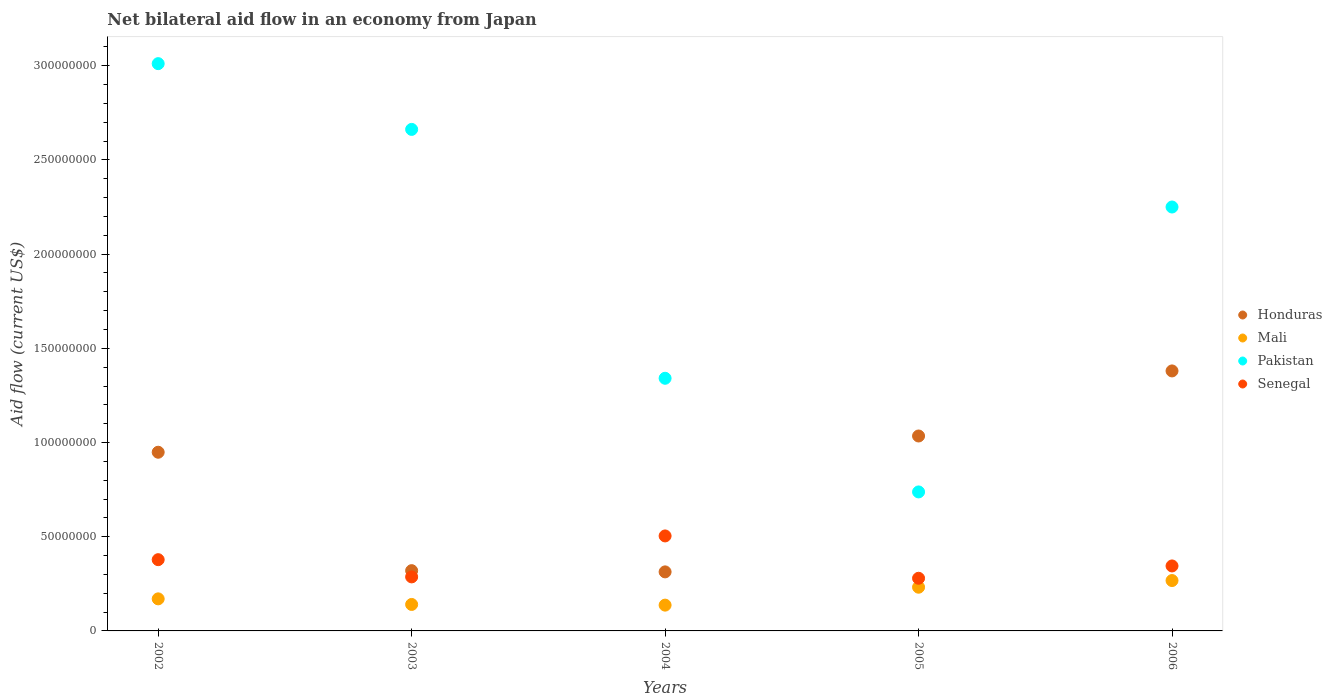Is the number of dotlines equal to the number of legend labels?
Your answer should be very brief. Yes. What is the net bilateral aid flow in Mali in 2002?
Give a very brief answer. 1.70e+07. Across all years, what is the maximum net bilateral aid flow in Pakistan?
Provide a succinct answer. 3.01e+08. Across all years, what is the minimum net bilateral aid flow in Mali?
Give a very brief answer. 1.37e+07. In which year was the net bilateral aid flow in Honduras minimum?
Provide a succinct answer. 2004. What is the total net bilateral aid flow in Senegal in the graph?
Make the answer very short. 1.79e+08. What is the difference between the net bilateral aid flow in Mali in 2002 and that in 2005?
Offer a terse response. -6.18e+06. What is the difference between the net bilateral aid flow in Mali in 2003 and the net bilateral aid flow in Senegal in 2005?
Give a very brief answer. -1.39e+07. What is the average net bilateral aid flow in Mali per year?
Ensure brevity in your answer.  1.89e+07. In the year 2004, what is the difference between the net bilateral aid flow in Mali and net bilateral aid flow in Senegal?
Offer a terse response. -3.67e+07. What is the ratio of the net bilateral aid flow in Honduras in 2004 to that in 2006?
Your answer should be very brief. 0.23. What is the difference between the highest and the second highest net bilateral aid flow in Honduras?
Ensure brevity in your answer.  3.45e+07. What is the difference between the highest and the lowest net bilateral aid flow in Honduras?
Provide a short and direct response. 1.07e+08. In how many years, is the net bilateral aid flow in Pakistan greater than the average net bilateral aid flow in Pakistan taken over all years?
Provide a short and direct response. 3. Is it the case that in every year, the sum of the net bilateral aid flow in Mali and net bilateral aid flow in Senegal  is greater than the sum of net bilateral aid flow in Honduras and net bilateral aid flow in Pakistan?
Your response must be concise. No. Is the net bilateral aid flow in Mali strictly less than the net bilateral aid flow in Honduras over the years?
Make the answer very short. Yes. How many dotlines are there?
Your response must be concise. 4. How many years are there in the graph?
Keep it short and to the point. 5. What is the difference between two consecutive major ticks on the Y-axis?
Keep it short and to the point. 5.00e+07. Does the graph contain any zero values?
Keep it short and to the point. No. Where does the legend appear in the graph?
Your answer should be compact. Center right. What is the title of the graph?
Keep it short and to the point. Net bilateral aid flow in an economy from Japan. What is the Aid flow (current US$) in Honduras in 2002?
Ensure brevity in your answer.  9.48e+07. What is the Aid flow (current US$) of Mali in 2002?
Your answer should be compact. 1.70e+07. What is the Aid flow (current US$) of Pakistan in 2002?
Make the answer very short. 3.01e+08. What is the Aid flow (current US$) in Senegal in 2002?
Offer a very short reply. 3.78e+07. What is the Aid flow (current US$) in Honduras in 2003?
Your answer should be compact. 3.20e+07. What is the Aid flow (current US$) of Mali in 2003?
Your answer should be compact. 1.40e+07. What is the Aid flow (current US$) of Pakistan in 2003?
Provide a succinct answer. 2.66e+08. What is the Aid flow (current US$) in Senegal in 2003?
Your response must be concise. 2.87e+07. What is the Aid flow (current US$) of Honduras in 2004?
Offer a terse response. 3.13e+07. What is the Aid flow (current US$) in Mali in 2004?
Your answer should be compact. 1.37e+07. What is the Aid flow (current US$) of Pakistan in 2004?
Your response must be concise. 1.34e+08. What is the Aid flow (current US$) in Senegal in 2004?
Your answer should be compact. 5.04e+07. What is the Aid flow (current US$) in Honduras in 2005?
Make the answer very short. 1.03e+08. What is the Aid flow (current US$) in Mali in 2005?
Give a very brief answer. 2.32e+07. What is the Aid flow (current US$) in Pakistan in 2005?
Your answer should be compact. 7.38e+07. What is the Aid flow (current US$) of Senegal in 2005?
Make the answer very short. 2.80e+07. What is the Aid flow (current US$) in Honduras in 2006?
Make the answer very short. 1.38e+08. What is the Aid flow (current US$) of Mali in 2006?
Provide a short and direct response. 2.67e+07. What is the Aid flow (current US$) of Pakistan in 2006?
Offer a very short reply. 2.25e+08. What is the Aid flow (current US$) in Senegal in 2006?
Provide a succinct answer. 3.45e+07. Across all years, what is the maximum Aid flow (current US$) of Honduras?
Your answer should be compact. 1.38e+08. Across all years, what is the maximum Aid flow (current US$) in Mali?
Provide a succinct answer. 2.67e+07. Across all years, what is the maximum Aid flow (current US$) of Pakistan?
Offer a terse response. 3.01e+08. Across all years, what is the maximum Aid flow (current US$) in Senegal?
Ensure brevity in your answer.  5.04e+07. Across all years, what is the minimum Aid flow (current US$) of Honduras?
Make the answer very short. 3.13e+07. Across all years, what is the minimum Aid flow (current US$) in Mali?
Make the answer very short. 1.37e+07. Across all years, what is the minimum Aid flow (current US$) of Pakistan?
Your response must be concise. 7.38e+07. Across all years, what is the minimum Aid flow (current US$) in Senegal?
Your response must be concise. 2.80e+07. What is the total Aid flow (current US$) in Honduras in the graph?
Keep it short and to the point. 4.00e+08. What is the total Aid flow (current US$) in Mali in the graph?
Your response must be concise. 9.47e+07. What is the total Aid flow (current US$) of Pakistan in the graph?
Provide a short and direct response. 1.00e+09. What is the total Aid flow (current US$) in Senegal in the graph?
Give a very brief answer. 1.79e+08. What is the difference between the Aid flow (current US$) in Honduras in 2002 and that in 2003?
Your response must be concise. 6.29e+07. What is the difference between the Aid flow (current US$) of Mali in 2002 and that in 2003?
Ensure brevity in your answer.  2.97e+06. What is the difference between the Aid flow (current US$) in Pakistan in 2002 and that in 2003?
Provide a short and direct response. 3.49e+07. What is the difference between the Aid flow (current US$) in Senegal in 2002 and that in 2003?
Offer a very short reply. 9.14e+06. What is the difference between the Aid flow (current US$) in Honduras in 2002 and that in 2004?
Keep it short and to the point. 6.35e+07. What is the difference between the Aid flow (current US$) in Mali in 2002 and that in 2004?
Your response must be concise. 3.33e+06. What is the difference between the Aid flow (current US$) of Pakistan in 2002 and that in 2004?
Your answer should be very brief. 1.67e+08. What is the difference between the Aid flow (current US$) of Senegal in 2002 and that in 2004?
Provide a succinct answer. -1.26e+07. What is the difference between the Aid flow (current US$) of Honduras in 2002 and that in 2005?
Give a very brief answer. -8.62e+06. What is the difference between the Aid flow (current US$) of Mali in 2002 and that in 2005?
Keep it short and to the point. -6.18e+06. What is the difference between the Aid flow (current US$) in Pakistan in 2002 and that in 2005?
Your answer should be very brief. 2.27e+08. What is the difference between the Aid flow (current US$) of Senegal in 2002 and that in 2005?
Make the answer very short. 9.87e+06. What is the difference between the Aid flow (current US$) of Honduras in 2002 and that in 2006?
Your answer should be compact. -4.32e+07. What is the difference between the Aid flow (current US$) of Mali in 2002 and that in 2006?
Give a very brief answer. -9.72e+06. What is the difference between the Aid flow (current US$) in Pakistan in 2002 and that in 2006?
Make the answer very short. 7.61e+07. What is the difference between the Aid flow (current US$) of Senegal in 2002 and that in 2006?
Ensure brevity in your answer.  3.33e+06. What is the difference between the Aid flow (current US$) of Honduras in 2003 and that in 2004?
Offer a terse response. 6.50e+05. What is the difference between the Aid flow (current US$) in Mali in 2003 and that in 2004?
Your response must be concise. 3.60e+05. What is the difference between the Aid flow (current US$) of Pakistan in 2003 and that in 2004?
Offer a terse response. 1.32e+08. What is the difference between the Aid flow (current US$) in Senegal in 2003 and that in 2004?
Provide a short and direct response. -2.17e+07. What is the difference between the Aid flow (current US$) in Honduras in 2003 and that in 2005?
Offer a very short reply. -7.15e+07. What is the difference between the Aid flow (current US$) of Mali in 2003 and that in 2005?
Your response must be concise. -9.15e+06. What is the difference between the Aid flow (current US$) in Pakistan in 2003 and that in 2005?
Provide a short and direct response. 1.92e+08. What is the difference between the Aid flow (current US$) in Senegal in 2003 and that in 2005?
Your answer should be very brief. 7.30e+05. What is the difference between the Aid flow (current US$) in Honduras in 2003 and that in 2006?
Offer a terse response. -1.06e+08. What is the difference between the Aid flow (current US$) in Mali in 2003 and that in 2006?
Your answer should be very brief. -1.27e+07. What is the difference between the Aid flow (current US$) in Pakistan in 2003 and that in 2006?
Your response must be concise. 4.12e+07. What is the difference between the Aid flow (current US$) in Senegal in 2003 and that in 2006?
Your response must be concise. -5.81e+06. What is the difference between the Aid flow (current US$) of Honduras in 2004 and that in 2005?
Provide a succinct answer. -7.21e+07. What is the difference between the Aid flow (current US$) of Mali in 2004 and that in 2005?
Offer a very short reply. -9.51e+06. What is the difference between the Aid flow (current US$) in Pakistan in 2004 and that in 2005?
Give a very brief answer. 6.03e+07. What is the difference between the Aid flow (current US$) of Senegal in 2004 and that in 2005?
Offer a very short reply. 2.25e+07. What is the difference between the Aid flow (current US$) of Honduras in 2004 and that in 2006?
Offer a very short reply. -1.07e+08. What is the difference between the Aid flow (current US$) of Mali in 2004 and that in 2006?
Offer a very short reply. -1.30e+07. What is the difference between the Aid flow (current US$) in Pakistan in 2004 and that in 2006?
Provide a succinct answer. -9.09e+07. What is the difference between the Aid flow (current US$) of Senegal in 2004 and that in 2006?
Your response must be concise. 1.59e+07. What is the difference between the Aid flow (current US$) of Honduras in 2005 and that in 2006?
Keep it short and to the point. -3.45e+07. What is the difference between the Aid flow (current US$) of Mali in 2005 and that in 2006?
Your response must be concise. -3.54e+06. What is the difference between the Aid flow (current US$) in Pakistan in 2005 and that in 2006?
Offer a terse response. -1.51e+08. What is the difference between the Aid flow (current US$) of Senegal in 2005 and that in 2006?
Keep it short and to the point. -6.54e+06. What is the difference between the Aid flow (current US$) in Honduras in 2002 and the Aid flow (current US$) in Mali in 2003?
Keep it short and to the point. 8.08e+07. What is the difference between the Aid flow (current US$) in Honduras in 2002 and the Aid flow (current US$) in Pakistan in 2003?
Offer a very short reply. -1.71e+08. What is the difference between the Aid flow (current US$) in Honduras in 2002 and the Aid flow (current US$) in Senegal in 2003?
Provide a short and direct response. 6.62e+07. What is the difference between the Aid flow (current US$) in Mali in 2002 and the Aid flow (current US$) in Pakistan in 2003?
Provide a succinct answer. -2.49e+08. What is the difference between the Aid flow (current US$) in Mali in 2002 and the Aid flow (current US$) in Senegal in 2003?
Provide a short and direct response. -1.17e+07. What is the difference between the Aid flow (current US$) in Pakistan in 2002 and the Aid flow (current US$) in Senegal in 2003?
Offer a terse response. 2.72e+08. What is the difference between the Aid flow (current US$) of Honduras in 2002 and the Aid flow (current US$) of Mali in 2004?
Provide a short and direct response. 8.12e+07. What is the difference between the Aid flow (current US$) of Honduras in 2002 and the Aid flow (current US$) of Pakistan in 2004?
Your response must be concise. -3.93e+07. What is the difference between the Aid flow (current US$) of Honduras in 2002 and the Aid flow (current US$) of Senegal in 2004?
Keep it short and to the point. 4.44e+07. What is the difference between the Aid flow (current US$) in Mali in 2002 and the Aid flow (current US$) in Pakistan in 2004?
Your answer should be compact. -1.17e+08. What is the difference between the Aid flow (current US$) in Mali in 2002 and the Aid flow (current US$) in Senegal in 2004?
Your answer should be very brief. -3.34e+07. What is the difference between the Aid flow (current US$) of Pakistan in 2002 and the Aid flow (current US$) of Senegal in 2004?
Provide a succinct answer. 2.51e+08. What is the difference between the Aid flow (current US$) in Honduras in 2002 and the Aid flow (current US$) in Mali in 2005?
Make the answer very short. 7.16e+07. What is the difference between the Aid flow (current US$) of Honduras in 2002 and the Aid flow (current US$) of Pakistan in 2005?
Your answer should be compact. 2.11e+07. What is the difference between the Aid flow (current US$) in Honduras in 2002 and the Aid flow (current US$) in Senegal in 2005?
Offer a very short reply. 6.69e+07. What is the difference between the Aid flow (current US$) in Mali in 2002 and the Aid flow (current US$) in Pakistan in 2005?
Ensure brevity in your answer.  -5.68e+07. What is the difference between the Aid flow (current US$) in Mali in 2002 and the Aid flow (current US$) in Senegal in 2005?
Your answer should be compact. -1.09e+07. What is the difference between the Aid flow (current US$) in Pakistan in 2002 and the Aid flow (current US$) in Senegal in 2005?
Your response must be concise. 2.73e+08. What is the difference between the Aid flow (current US$) of Honduras in 2002 and the Aid flow (current US$) of Mali in 2006?
Your answer should be very brief. 6.81e+07. What is the difference between the Aid flow (current US$) of Honduras in 2002 and the Aid flow (current US$) of Pakistan in 2006?
Ensure brevity in your answer.  -1.30e+08. What is the difference between the Aid flow (current US$) in Honduras in 2002 and the Aid flow (current US$) in Senegal in 2006?
Provide a succinct answer. 6.04e+07. What is the difference between the Aid flow (current US$) of Mali in 2002 and the Aid flow (current US$) of Pakistan in 2006?
Provide a short and direct response. -2.08e+08. What is the difference between the Aid flow (current US$) of Mali in 2002 and the Aid flow (current US$) of Senegal in 2006?
Keep it short and to the point. -1.75e+07. What is the difference between the Aid flow (current US$) in Pakistan in 2002 and the Aid flow (current US$) in Senegal in 2006?
Offer a terse response. 2.67e+08. What is the difference between the Aid flow (current US$) in Honduras in 2003 and the Aid flow (current US$) in Mali in 2004?
Provide a short and direct response. 1.83e+07. What is the difference between the Aid flow (current US$) of Honduras in 2003 and the Aid flow (current US$) of Pakistan in 2004?
Provide a succinct answer. -1.02e+08. What is the difference between the Aid flow (current US$) in Honduras in 2003 and the Aid flow (current US$) in Senegal in 2004?
Offer a very short reply. -1.84e+07. What is the difference between the Aid flow (current US$) of Mali in 2003 and the Aid flow (current US$) of Pakistan in 2004?
Your answer should be very brief. -1.20e+08. What is the difference between the Aid flow (current US$) of Mali in 2003 and the Aid flow (current US$) of Senegal in 2004?
Provide a short and direct response. -3.64e+07. What is the difference between the Aid flow (current US$) of Pakistan in 2003 and the Aid flow (current US$) of Senegal in 2004?
Keep it short and to the point. 2.16e+08. What is the difference between the Aid flow (current US$) in Honduras in 2003 and the Aid flow (current US$) in Mali in 2005?
Make the answer very short. 8.79e+06. What is the difference between the Aid flow (current US$) in Honduras in 2003 and the Aid flow (current US$) in Pakistan in 2005?
Provide a succinct answer. -4.18e+07. What is the difference between the Aid flow (current US$) in Honduras in 2003 and the Aid flow (current US$) in Senegal in 2005?
Make the answer very short. 4.04e+06. What is the difference between the Aid flow (current US$) in Mali in 2003 and the Aid flow (current US$) in Pakistan in 2005?
Provide a succinct answer. -5.97e+07. What is the difference between the Aid flow (current US$) in Mali in 2003 and the Aid flow (current US$) in Senegal in 2005?
Offer a terse response. -1.39e+07. What is the difference between the Aid flow (current US$) in Pakistan in 2003 and the Aid flow (current US$) in Senegal in 2005?
Offer a terse response. 2.38e+08. What is the difference between the Aid flow (current US$) of Honduras in 2003 and the Aid flow (current US$) of Mali in 2006?
Offer a very short reply. 5.25e+06. What is the difference between the Aid flow (current US$) in Honduras in 2003 and the Aid flow (current US$) in Pakistan in 2006?
Your answer should be very brief. -1.93e+08. What is the difference between the Aid flow (current US$) in Honduras in 2003 and the Aid flow (current US$) in Senegal in 2006?
Offer a terse response. -2.50e+06. What is the difference between the Aid flow (current US$) in Mali in 2003 and the Aid flow (current US$) in Pakistan in 2006?
Your answer should be very brief. -2.11e+08. What is the difference between the Aid flow (current US$) in Mali in 2003 and the Aid flow (current US$) in Senegal in 2006?
Keep it short and to the point. -2.04e+07. What is the difference between the Aid flow (current US$) of Pakistan in 2003 and the Aid flow (current US$) of Senegal in 2006?
Offer a very short reply. 2.32e+08. What is the difference between the Aid flow (current US$) in Honduras in 2004 and the Aid flow (current US$) in Mali in 2005?
Offer a very short reply. 8.14e+06. What is the difference between the Aid flow (current US$) of Honduras in 2004 and the Aid flow (current US$) of Pakistan in 2005?
Offer a very short reply. -4.24e+07. What is the difference between the Aid flow (current US$) of Honduras in 2004 and the Aid flow (current US$) of Senegal in 2005?
Keep it short and to the point. 3.39e+06. What is the difference between the Aid flow (current US$) of Mali in 2004 and the Aid flow (current US$) of Pakistan in 2005?
Provide a short and direct response. -6.01e+07. What is the difference between the Aid flow (current US$) of Mali in 2004 and the Aid flow (current US$) of Senegal in 2005?
Your answer should be compact. -1.43e+07. What is the difference between the Aid flow (current US$) in Pakistan in 2004 and the Aid flow (current US$) in Senegal in 2005?
Make the answer very short. 1.06e+08. What is the difference between the Aid flow (current US$) in Honduras in 2004 and the Aid flow (current US$) in Mali in 2006?
Provide a short and direct response. 4.60e+06. What is the difference between the Aid flow (current US$) in Honduras in 2004 and the Aid flow (current US$) in Pakistan in 2006?
Provide a succinct answer. -1.94e+08. What is the difference between the Aid flow (current US$) of Honduras in 2004 and the Aid flow (current US$) of Senegal in 2006?
Ensure brevity in your answer.  -3.15e+06. What is the difference between the Aid flow (current US$) of Mali in 2004 and the Aid flow (current US$) of Pakistan in 2006?
Give a very brief answer. -2.11e+08. What is the difference between the Aid flow (current US$) in Mali in 2004 and the Aid flow (current US$) in Senegal in 2006?
Keep it short and to the point. -2.08e+07. What is the difference between the Aid flow (current US$) of Pakistan in 2004 and the Aid flow (current US$) of Senegal in 2006?
Offer a very short reply. 9.96e+07. What is the difference between the Aid flow (current US$) in Honduras in 2005 and the Aid flow (current US$) in Mali in 2006?
Your response must be concise. 7.67e+07. What is the difference between the Aid flow (current US$) of Honduras in 2005 and the Aid flow (current US$) of Pakistan in 2006?
Your response must be concise. -1.22e+08. What is the difference between the Aid flow (current US$) of Honduras in 2005 and the Aid flow (current US$) of Senegal in 2006?
Offer a terse response. 6.90e+07. What is the difference between the Aid flow (current US$) in Mali in 2005 and the Aid flow (current US$) in Pakistan in 2006?
Your answer should be compact. -2.02e+08. What is the difference between the Aid flow (current US$) in Mali in 2005 and the Aid flow (current US$) in Senegal in 2006?
Provide a succinct answer. -1.13e+07. What is the difference between the Aid flow (current US$) in Pakistan in 2005 and the Aid flow (current US$) in Senegal in 2006?
Ensure brevity in your answer.  3.93e+07. What is the average Aid flow (current US$) in Honduras per year?
Your answer should be compact. 7.99e+07. What is the average Aid flow (current US$) in Mali per year?
Provide a short and direct response. 1.89e+07. What is the average Aid flow (current US$) of Pakistan per year?
Offer a terse response. 2.00e+08. What is the average Aid flow (current US$) of Senegal per year?
Your answer should be very brief. 3.59e+07. In the year 2002, what is the difference between the Aid flow (current US$) of Honduras and Aid flow (current US$) of Mali?
Keep it short and to the point. 7.78e+07. In the year 2002, what is the difference between the Aid flow (current US$) in Honduras and Aid flow (current US$) in Pakistan?
Give a very brief answer. -2.06e+08. In the year 2002, what is the difference between the Aid flow (current US$) in Honduras and Aid flow (current US$) in Senegal?
Ensure brevity in your answer.  5.70e+07. In the year 2002, what is the difference between the Aid flow (current US$) in Mali and Aid flow (current US$) in Pakistan?
Provide a short and direct response. -2.84e+08. In the year 2002, what is the difference between the Aid flow (current US$) of Mali and Aid flow (current US$) of Senegal?
Your answer should be very brief. -2.08e+07. In the year 2002, what is the difference between the Aid flow (current US$) of Pakistan and Aid flow (current US$) of Senegal?
Your answer should be very brief. 2.63e+08. In the year 2003, what is the difference between the Aid flow (current US$) of Honduras and Aid flow (current US$) of Mali?
Give a very brief answer. 1.79e+07. In the year 2003, what is the difference between the Aid flow (current US$) of Honduras and Aid flow (current US$) of Pakistan?
Your answer should be very brief. -2.34e+08. In the year 2003, what is the difference between the Aid flow (current US$) of Honduras and Aid flow (current US$) of Senegal?
Your answer should be very brief. 3.31e+06. In the year 2003, what is the difference between the Aid flow (current US$) in Mali and Aid flow (current US$) in Pakistan?
Provide a succinct answer. -2.52e+08. In the year 2003, what is the difference between the Aid flow (current US$) of Mali and Aid flow (current US$) of Senegal?
Offer a terse response. -1.46e+07. In the year 2003, what is the difference between the Aid flow (current US$) in Pakistan and Aid flow (current US$) in Senegal?
Give a very brief answer. 2.38e+08. In the year 2004, what is the difference between the Aid flow (current US$) of Honduras and Aid flow (current US$) of Mali?
Make the answer very short. 1.76e+07. In the year 2004, what is the difference between the Aid flow (current US$) of Honduras and Aid flow (current US$) of Pakistan?
Your response must be concise. -1.03e+08. In the year 2004, what is the difference between the Aid flow (current US$) in Honduras and Aid flow (current US$) in Senegal?
Offer a very short reply. -1.91e+07. In the year 2004, what is the difference between the Aid flow (current US$) of Mali and Aid flow (current US$) of Pakistan?
Offer a terse response. -1.20e+08. In the year 2004, what is the difference between the Aid flow (current US$) in Mali and Aid flow (current US$) in Senegal?
Offer a terse response. -3.67e+07. In the year 2004, what is the difference between the Aid flow (current US$) of Pakistan and Aid flow (current US$) of Senegal?
Offer a terse response. 8.37e+07. In the year 2005, what is the difference between the Aid flow (current US$) in Honduras and Aid flow (current US$) in Mali?
Ensure brevity in your answer.  8.03e+07. In the year 2005, what is the difference between the Aid flow (current US$) in Honduras and Aid flow (current US$) in Pakistan?
Your answer should be compact. 2.97e+07. In the year 2005, what is the difference between the Aid flow (current US$) of Honduras and Aid flow (current US$) of Senegal?
Provide a short and direct response. 7.55e+07. In the year 2005, what is the difference between the Aid flow (current US$) of Mali and Aid flow (current US$) of Pakistan?
Keep it short and to the point. -5.06e+07. In the year 2005, what is the difference between the Aid flow (current US$) of Mali and Aid flow (current US$) of Senegal?
Your response must be concise. -4.75e+06. In the year 2005, what is the difference between the Aid flow (current US$) of Pakistan and Aid flow (current US$) of Senegal?
Make the answer very short. 4.58e+07. In the year 2006, what is the difference between the Aid flow (current US$) in Honduras and Aid flow (current US$) in Mali?
Your answer should be very brief. 1.11e+08. In the year 2006, what is the difference between the Aid flow (current US$) in Honduras and Aid flow (current US$) in Pakistan?
Provide a short and direct response. -8.70e+07. In the year 2006, what is the difference between the Aid flow (current US$) of Honduras and Aid flow (current US$) of Senegal?
Your answer should be very brief. 1.04e+08. In the year 2006, what is the difference between the Aid flow (current US$) in Mali and Aid flow (current US$) in Pakistan?
Your answer should be very brief. -1.98e+08. In the year 2006, what is the difference between the Aid flow (current US$) of Mali and Aid flow (current US$) of Senegal?
Your answer should be compact. -7.75e+06. In the year 2006, what is the difference between the Aid flow (current US$) in Pakistan and Aid flow (current US$) in Senegal?
Make the answer very short. 1.91e+08. What is the ratio of the Aid flow (current US$) in Honduras in 2002 to that in 2003?
Provide a succinct answer. 2.96. What is the ratio of the Aid flow (current US$) of Mali in 2002 to that in 2003?
Provide a succinct answer. 1.21. What is the ratio of the Aid flow (current US$) in Pakistan in 2002 to that in 2003?
Offer a terse response. 1.13. What is the ratio of the Aid flow (current US$) of Senegal in 2002 to that in 2003?
Your answer should be compact. 1.32. What is the ratio of the Aid flow (current US$) of Honduras in 2002 to that in 2004?
Make the answer very short. 3.03. What is the ratio of the Aid flow (current US$) in Mali in 2002 to that in 2004?
Give a very brief answer. 1.24. What is the ratio of the Aid flow (current US$) in Pakistan in 2002 to that in 2004?
Provide a succinct answer. 2.25. What is the ratio of the Aid flow (current US$) of Senegal in 2002 to that in 2004?
Your answer should be very brief. 0.75. What is the ratio of the Aid flow (current US$) of Honduras in 2002 to that in 2005?
Provide a short and direct response. 0.92. What is the ratio of the Aid flow (current US$) in Mali in 2002 to that in 2005?
Offer a terse response. 0.73. What is the ratio of the Aid flow (current US$) of Pakistan in 2002 to that in 2005?
Ensure brevity in your answer.  4.08. What is the ratio of the Aid flow (current US$) of Senegal in 2002 to that in 2005?
Make the answer very short. 1.35. What is the ratio of the Aid flow (current US$) of Honduras in 2002 to that in 2006?
Ensure brevity in your answer.  0.69. What is the ratio of the Aid flow (current US$) in Mali in 2002 to that in 2006?
Your answer should be compact. 0.64. What is the ratio of the Aid flow (current US$) in Pakistan in 2002 to that in 2006?
Your response must be concise. 1.34. What is the ratio of the Aid flow (current US$) of Senegal in 2002 to that in 2006?
Keep it short and to the point. 1.1. What is the ratio of the Aid flow (current US$) of Honduras in 2003 to that in 2004?
Provide a short and direct response. 1.02. What is the ratio of the Aid flow (current US$) of Mali in 2003 to that in 2004?
Your answer should be very brief. 1.03. What is the ratio of the Aid flow (current US$) in Pakistan in 2003 to that in 2004?
Keep it short and to the point. 1.99. What is the ratio of the Aid flow (current US$) of Senegal in 2003 to that in 2004?
Provide a short and direct response. 0.57. What is the ratio of the Aid flow (current US$) of Honduras in 2003 to that in 2005?
Give a very brief answer. 0.31. What is the ratio of the Aid flow (current US$) of Mali in 2003 to that in 2005?
Your answer should be very brief. 0.61. What is the ratio of the Aid flow (current US$) in Pakistan in 2003 to that in 2005?
Offer a very short reply. 3.61. What is the ratio of the Aid flow (current US$) in Senegal in 2003 to that in 2005?
Your response must be concise. 1.03. What is the ratio of the Aid flow (current US$) of Honduras in 2003 to that in 2006?
Keep it short and to the point. 0.23. What is the ratio of the Aid flow (current US$) in Mali in 2003 to that in 2006?
Your response must be concise. 0.53. What is the ratio of the Aid flow (current US$) in Pakistan in 2003 to that in 2006?
Provide a succinct answer. 1.18. What is the ratio of the Aid flow (current US$) in Senegal in 2003 to that in 2006?
Make the answer very short. 0.83. What is the ratio of the Aid flow (current US$) in Honduras in 2004 to that in 2005?
Your response must be concise. 0.3. What is the ratio of the Aid flow (current US$) in Mali in 2004 to that in 2005?
Provide a short and direct response. 0.59. What is the ratio of the Aid flow (current US$) of Pakistan in 2004 to that in 2005?
Provide a short and direct response. 1.82. What is the ratio of the Aid flow (current US$) in Senegal in 2004 to that in 2005?
Your answer should be compact. 1.8. What is the ratio of the Aid flow (current US$) of Honduras in 2004 to that in 2006?
Offer a terse response. 0.23. What is the ratio of the Aid flow (current US$) in Mali in 2004 to that in 2006?
Make the answer very short. 0.51. What is the ratio of the Aid flow (current US$) in Pakistan in 2004 to that in 2006?
Provide a succinct answer. 0.6. What is the ratio of the Aid flow (current US$) of Senegal in 2004 to that in 2006?
Provide a short and direct response. 1.46. What is the ratio of the Aid flow (current US$) of Honduras in 2005 to that in 2006?
Your response must be concise. 0.75. What is the ratio of the Aid flow (current US$) of Mali in 2005 to that in 2006?
Offer a terse response. 0.87. What is the ratio of the Aid flow (current US$) of Pakistan in 2005 to that in 2006?
Provide a succinct answer. 0.33. What is the ratio of the Aid flow (current US$) of Senegal in 2005 to that in 2006?
Ensure brevity in your answer.  0.81. What is the difference between the highest and the second highest Aid flow (current US$) in Honduras?
Provide a short and direct response. 3.45e+07. What is the difference between the highest and the second highest Aid flow (current US$) of Mali?
Give a very brief answer. 3.54e+06. What is the difference between the highest and the second highest Aid flow (current US$) in Pakistan?
Offer a very short reply. 3.49e+07. What is the difference between the highest and the second highest Aid flow (current US$) in Senegal?
Your answer should be compact. 1.26e+07. What is the difference between the highest and the lowest Aid flow (current US$) in Honduras?
Make the answer very short. 1.07e+08. What is the difference between the highest and the lowest Aid flow (current US$) of Mali?
Give a very brief answer. 1.30e+07. What is the difference between the highest and the lowest Aid flow (current US$) in Pakistan?
Your response must be concise. 2.27e+08. What is the difference between the highest and the lowest Aid flow (current US$) of Senegal?
Your response must be concise. 2.25e+07. 